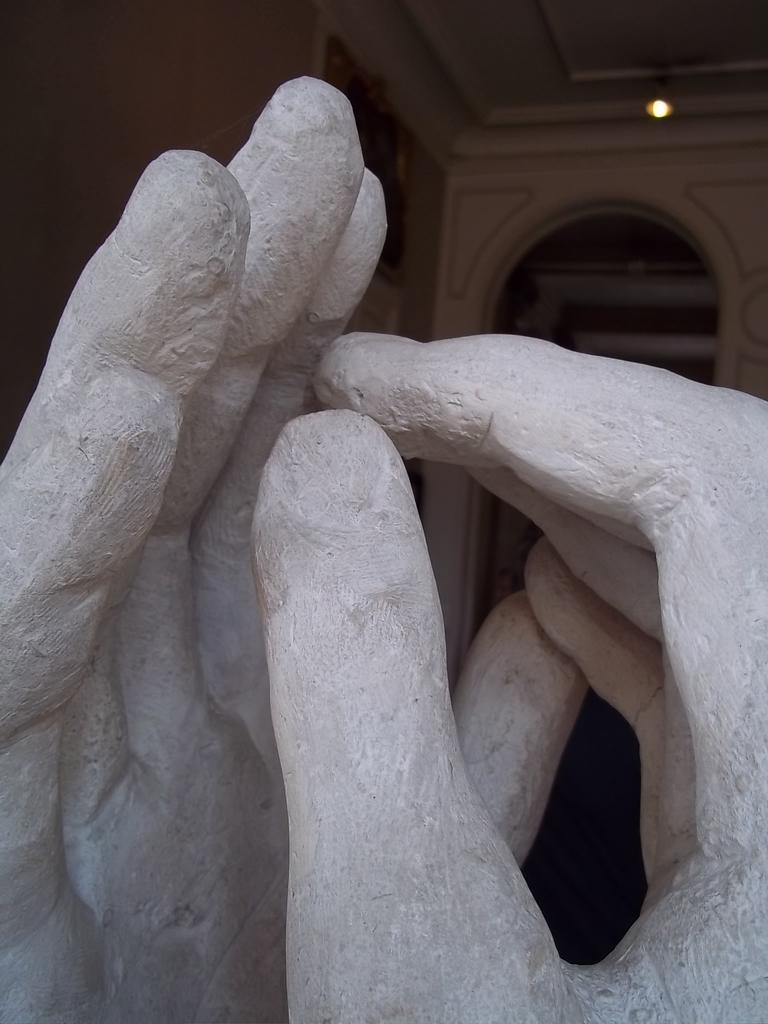How would you summarize this image in a sentence or two? In this image we can see the sculpture. On the backside we can see a wall and a roof. 